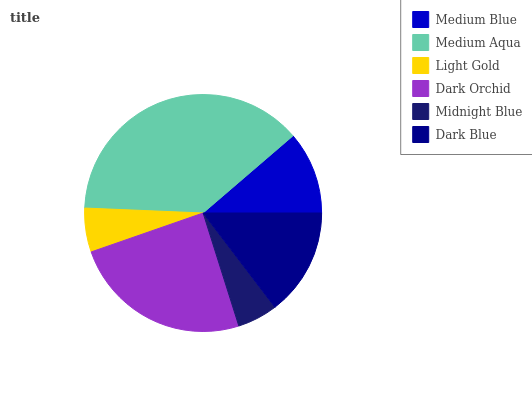Is Midnight Blue the minimum?
Answer yes or no. Yes. Is Medium Aqua the maximum?
Answer yes or no. Yes. Is Light Gold the minimum?
Answer yes or no. No. Is Light Gold the maximum?
Answer yes or no. No. Is Medium Aqua greater than Light Gold?
Answer yes or no. Yes. Is Light Gold less than Medium Aqua?
Answer yes or no. Yes. Is Light Gold greater than Medium Aqua?
Answer yes or no. No. Is Medium Aqua less than Light Gold?
Answer yes or no. No. Is Dark Blue the high median?
Answer yes or no. Yes. Is Medium Blue the low median?
Answer yes or no. Yes. Is Midnight Blue the high median?
Answer yes or no. No. Is Dark Orchid the low median?
Answer yes or no. No. 